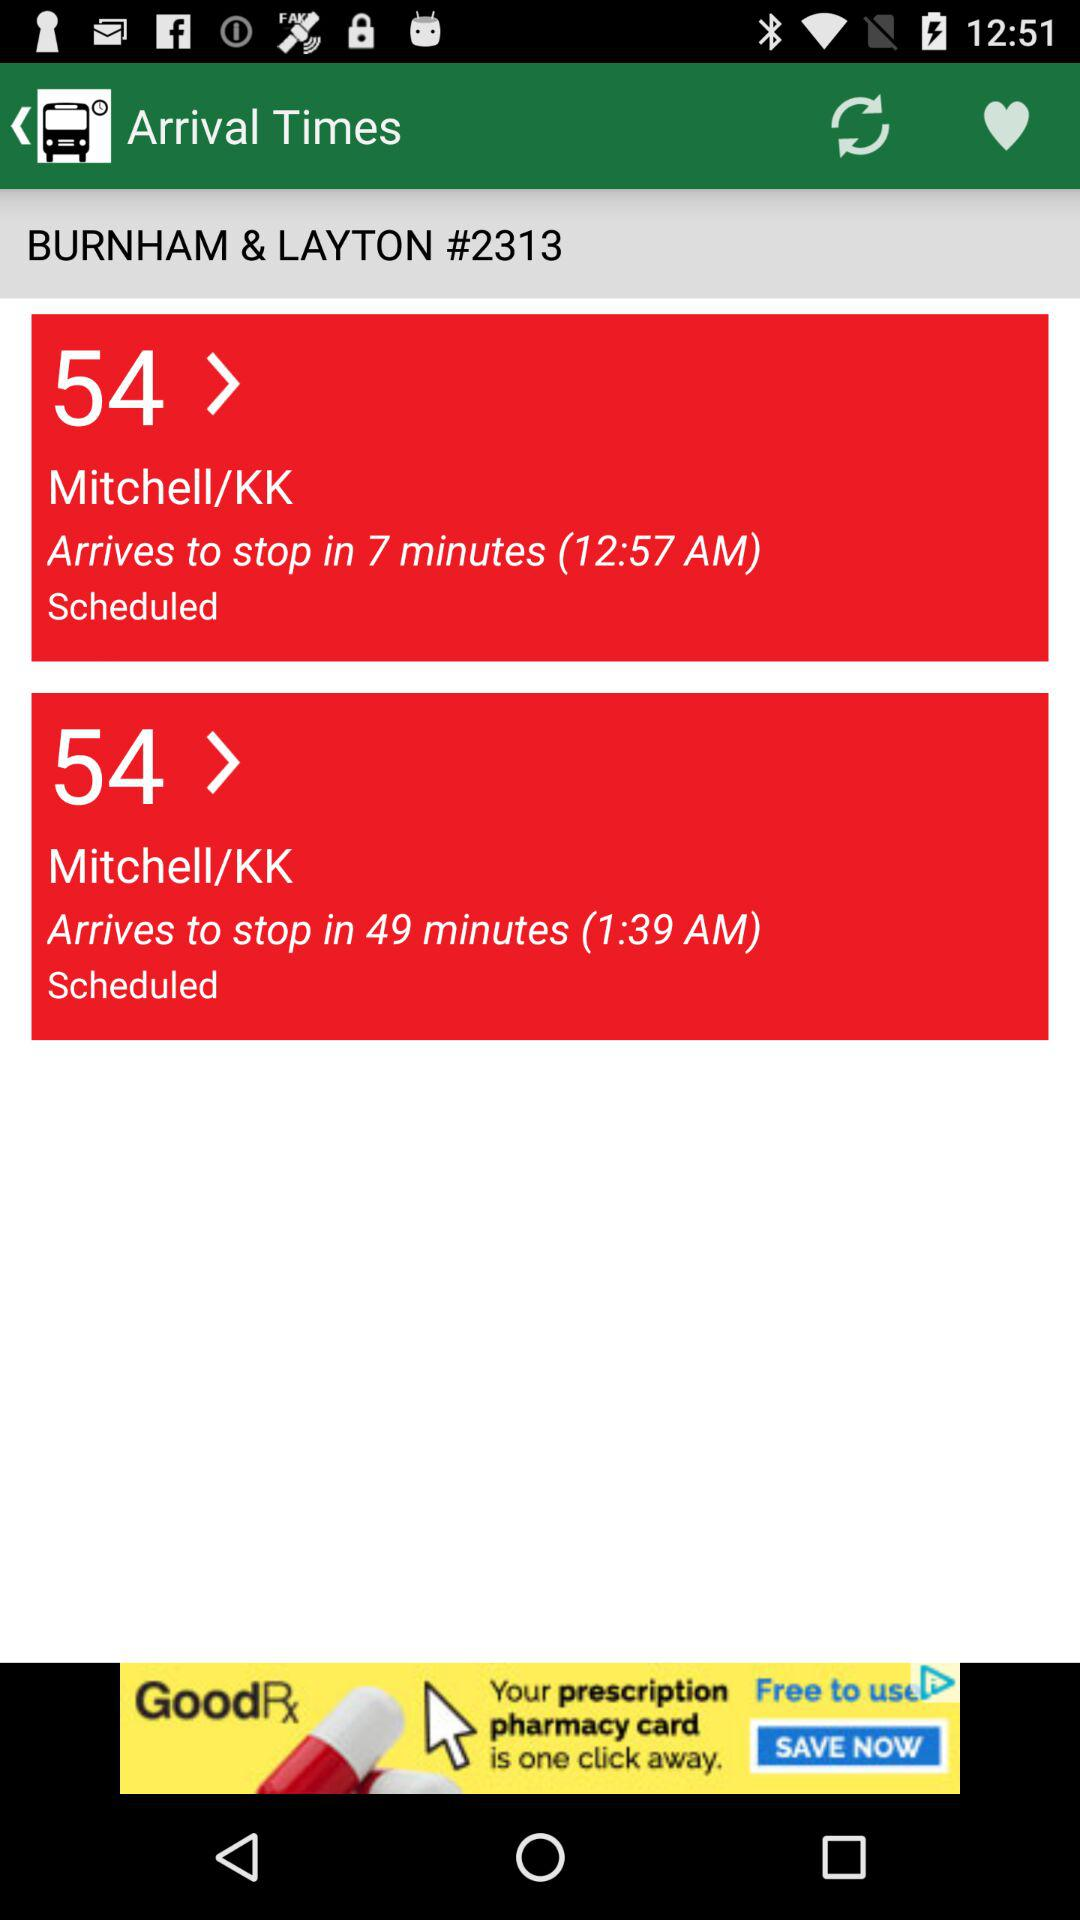How many minutes later is the second bus scheduled to arrive?
Answer the question using a single word or phrase. 42 